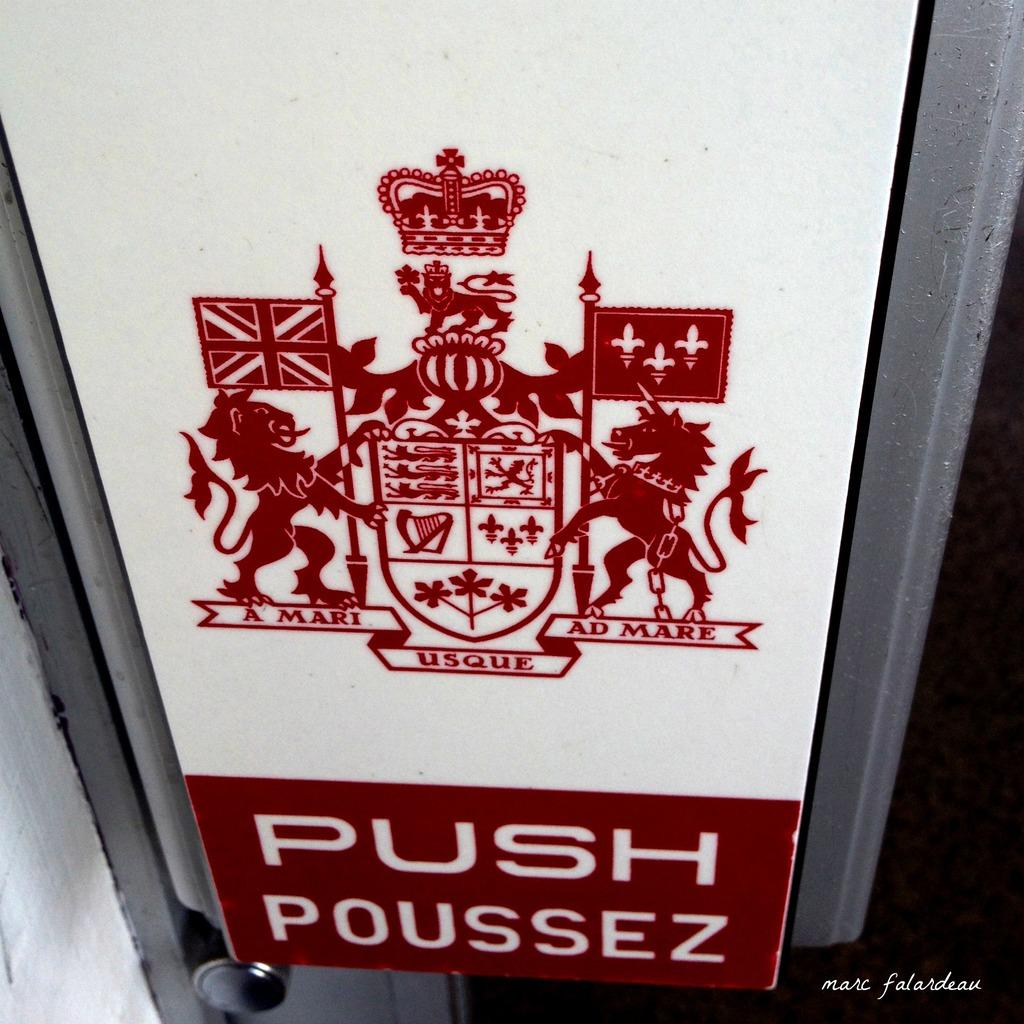<image>
Give a short and clear explanation of the subsequent image. A sign with latin words A Mari Usque Ad Mare for a Push sign 